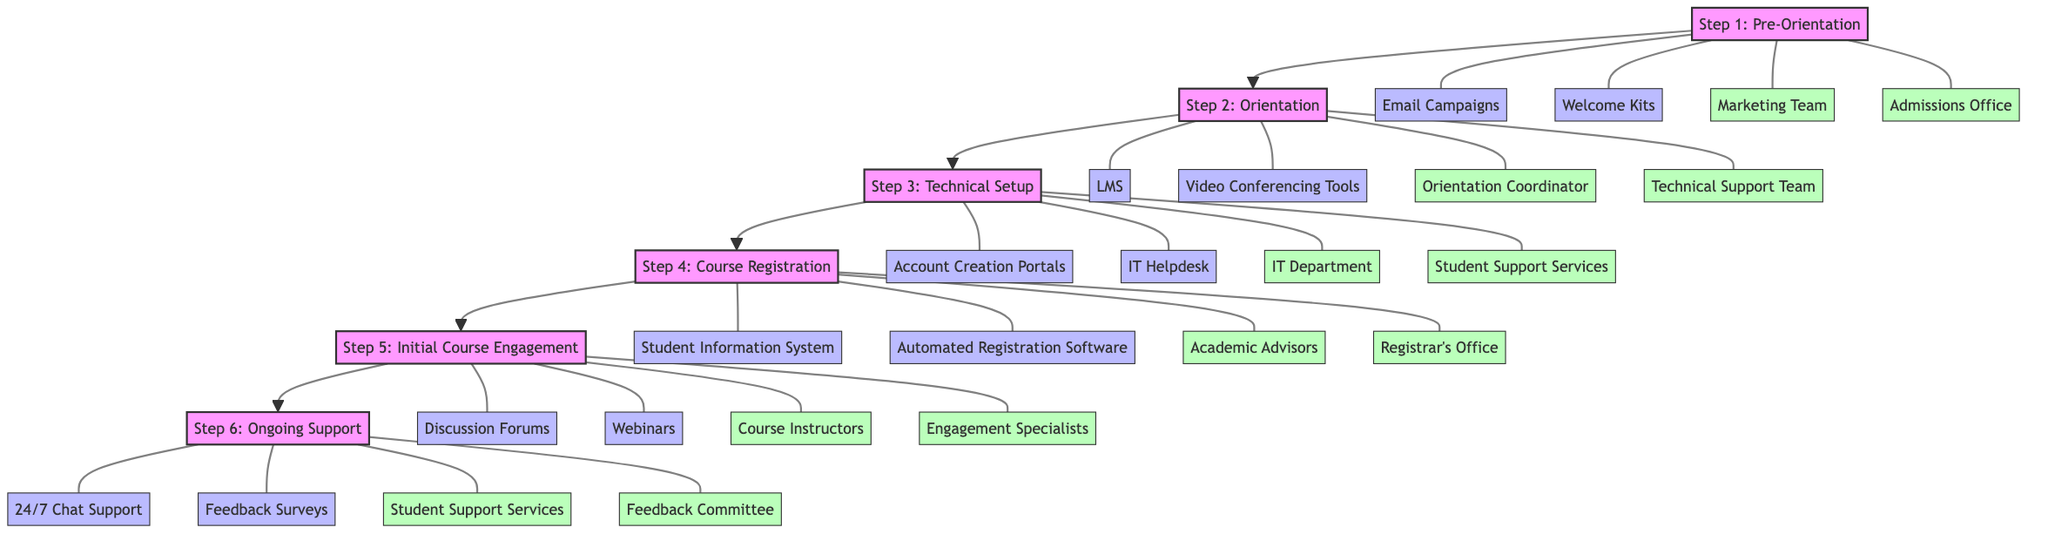What is the first step in the onboarding process? The first step in the diagram is labeled as "Step 1: Pre-Orientation." It is connected to other steps sequentially, showing the flow of the onboarding process.
Answer: Step 1: Pre-Orientation How many tools are listed under Step 5? Under Step 5, there are two tools mentioned: "Discussion Forums" and "Webinars." By counting the tools connected to Step 5, we find that there are exactly two.
Answer: 2 Who is responsible for Step 2? The responsibilities for Step 2 are shared between "Orientation Coordinator" and "Technical Support Team." By looking at the connections from Step 2, we identify these two groups as responsible parties.
Answer: Orientation Coordinator, Technical Support Team What tools are used during Step 3? The tools listed for Step 3 include "Account Creation Portals" and "IT Helpdesk." By reviewing the relevant connections for Step 3, we can directly identify these two tools involved in the technical setup process.
Answer: Account Creation Portals, IT Helpdesk What is the relationship between Step 4 and Step 5? Step 4 leads directly to Step 5 in the diagram. This connection indicates that after completing the Course Registration in Step 4, the process flows into Initial Course Engagement in Step 5, demonstrating a sequential relationship.
Answer: Sequential Which department is responsible for ongoing support? Step 6 indicates that "Student Support Services" and "Feedback Committee" are responsible for ongoing support. By examining the connections to Step 6, we can identify these two departments as accountable for this step.
Answer: Student Support Services, Feedback Committee How many steps are in the onboarding process? The diagram outlines six steps from Pre-Orientation through Ongoing Support. By counting each distinct step in the flowchart, we determine there are six steps in total.
Answer: 6 Which tools are associated with Step 1? The tools for Step 1 are "Email Campaigns" and "Welcome Kits." By looking at the connections branching from Step 1, we can see these two tools are explicitly linked to this initial step of the onboarding process.
Answer: Email Campaigns, Welcome Kits Which group is involved in "Initial Course Engagement"? The responsibilities for Step 5 include "Course Instructors" and "Engagement Specialists." By checking the connections related to the Initial Course Engagement step, we can clearly identify these two groups as the ones involved.
Answer: Course Instructors, Engagement Specialists 